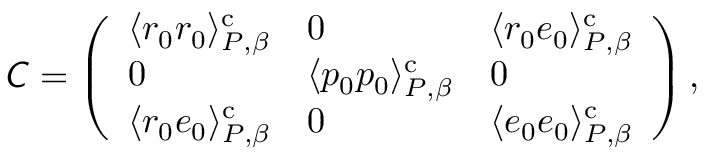<formula> <loc_0><loc_0><loc_500><loc_500>\mathsf i t { C } = \left ( \begin{array} { l l l } { \langle r _ { 0 } r _ { 0 } \rangle _ { P , \beta } ^ { c } } & { 0 } & { \langle r _ { 0 } e _ { 0 } \rangle _ { P , \beta } ^ { c } } \\ { 0 } & { \langle p _ { 0 } p _ { 0 } \rangle _ { P , \beta } ^ { c } } & { 0 } \\ { \langle r _ { 0 } e _ { 0 } \rangle _ { P , \beta } ^ { c } } & { 0 } & { \langle e _ { 0 } e _ { 0 } \rangle _ { P , \beta } ^ { c } } \end{array} \right ) ,</formula> 